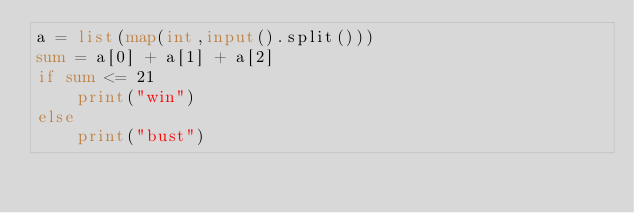<code> <loc_0><loc_0><loc_500><loc_500><_Python_>a = list(map(int,input().split()))
sum = a[0] + a[1] + a[2]
if sum <= 21
	print("win")
else
	print("bust")</code> 